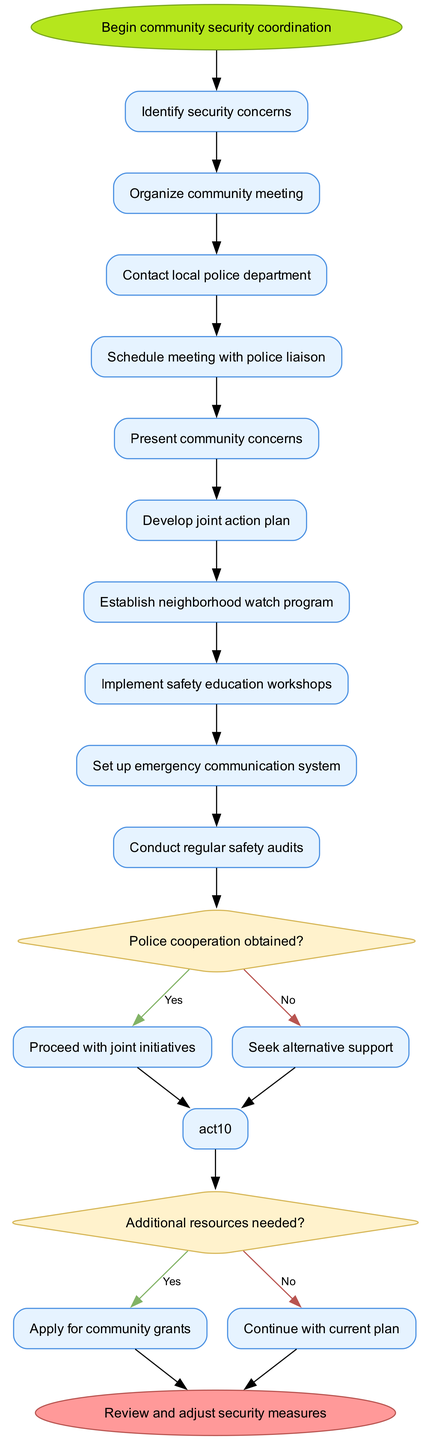What is the first activity in the diagram? The first activity is the one directly connected to the start node, which is "Identify security concerns."
Answer: Identify security concerns How many activities are there in total? By counting the list of activities provided in the diagram, there are 10 activities listed.
Answer: 10 What happens if police cooperation is not obtained? Following the decision from the diamond node regarding police cooperation, if the answer is "No," the next step is to seek alternative support.
Answer: Seek alternative support What is the last activity before reaching the end node? The last activity before the end node, based on the flow of the activities, is "Conduct regular safety audits."
Answer: Conduct regular safety audits What is needed if additional resources are required? If additional resources are deemed necessary, the next action in the decision flow is to apply for community grants.
Answer: Apply for community grants How many decision nodes are present in the diagram? There are two decision nodes that ask questions regarding police cooperation and resource needs respectively.
Answer: 2 What is the shape of the end node? The end node is represented as an oval shape, as specified for the end of the activity diagram.
Answer: Oval What is the outcome if additional resources are not needed? If the answer to the question about additional resources needed is "No," the flow continues with the current plan.
Answer: Continue with current plan What is the purpose of scheduling a meeting with the police liaison? The scheduling of a meeting with the police liaison is essential for discussing and addressing community security concerns with law enforcement.
Answer: Discuss community concerns 